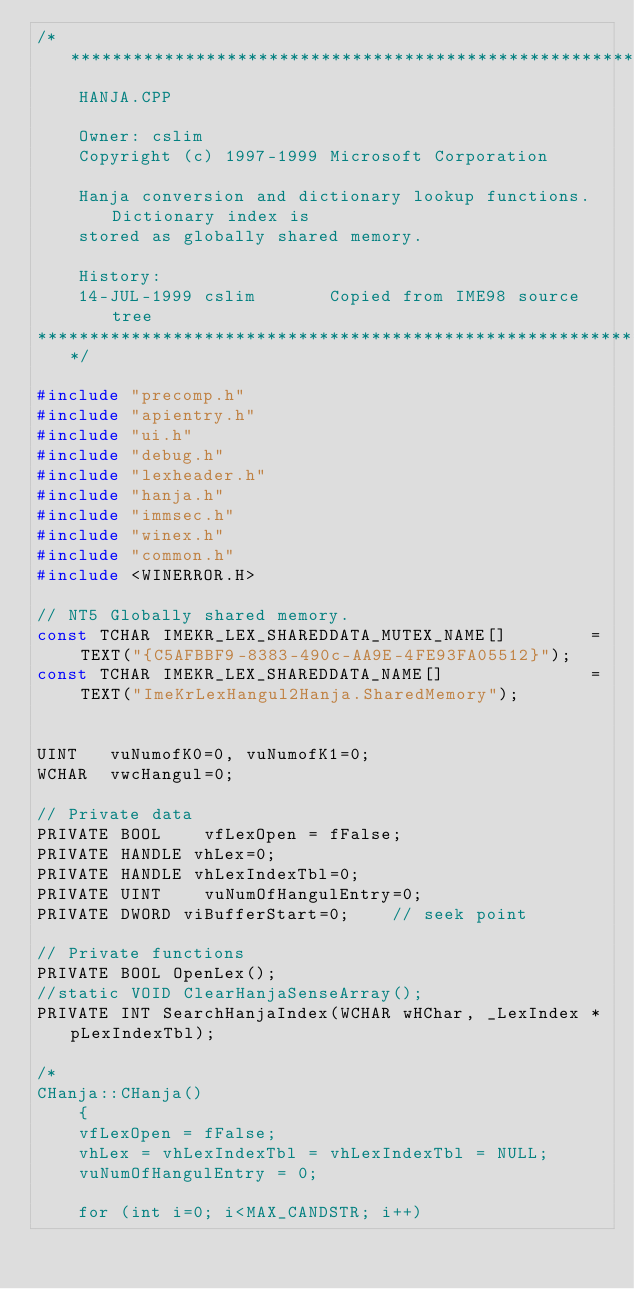Convert code to text. <code><loc_0><loc_0><loc_500><loc_500><_C++_>/****************************************************************************
    HANJA.CPP

    Owner: cslim
    Copyright (c) 1997-1999 Microsoft Corporation

    Hanja conversion and dictionary lookup functions. Dictionary index is 
    stored as globally shared memory.
    
    History:
    14-JUL-1999 cslim       Copied from IME98 source tree
*****************************************************************************/

#include "precomp.h"
#include "apientry.h"
#include "ui.h"
#include "debug.h"
#include "lexheader.h"
#include "hanja.h"
#include "immsec.h"
#include "winex.h"
#include "common.h"
#include <WINERROR.H>

// NT5 Globally shared memory. 
const TCHAR IMEKR_LEX_SHAREDDATA_MUTEX_NAME[]        = TEXT("{C5AFBBF9-8383-490c-AA9E-4FE93FA05512}");
const TCHAR IMEKR_LEX_SHAREDDATA_NAME[]              = TEXT("ImeKrLexHangul2Hanja.SharedMemory");


UINT   vuNumofK0=0, vuNumofK1=0;
WCHAR  vwcHangul=0;

// Private data
PRIVATE BOOL    vfLexOpen = fFalse;
PRIVATE HANDLE vhLex=0;
PRIVATE HANDLE vhLexIndexTbl=0;
PRIVATE UINT    vuNumOfHangulEntry=0;
PRIVATE DWORD viBufferStart=0;    // seek point

// Private functions
PRIVATE BOOL OpenLex();
//static VOID ClearHanjaSenseArray();
PRIVATE INT SearchHanjaIndex(WCHAR wHChar, _LexIndex *pLexIndexTbl);

/*
CHanja::CHanja()
    {
    vfLexOpen = fFalse;
    vhLex = vhLexIndexTbl = vhLexIndexTbl = NULL;
    vuNumOfHangulEntry = 0;

    for (int i=0; i<MAX_CANDSTR; i++) </code> 